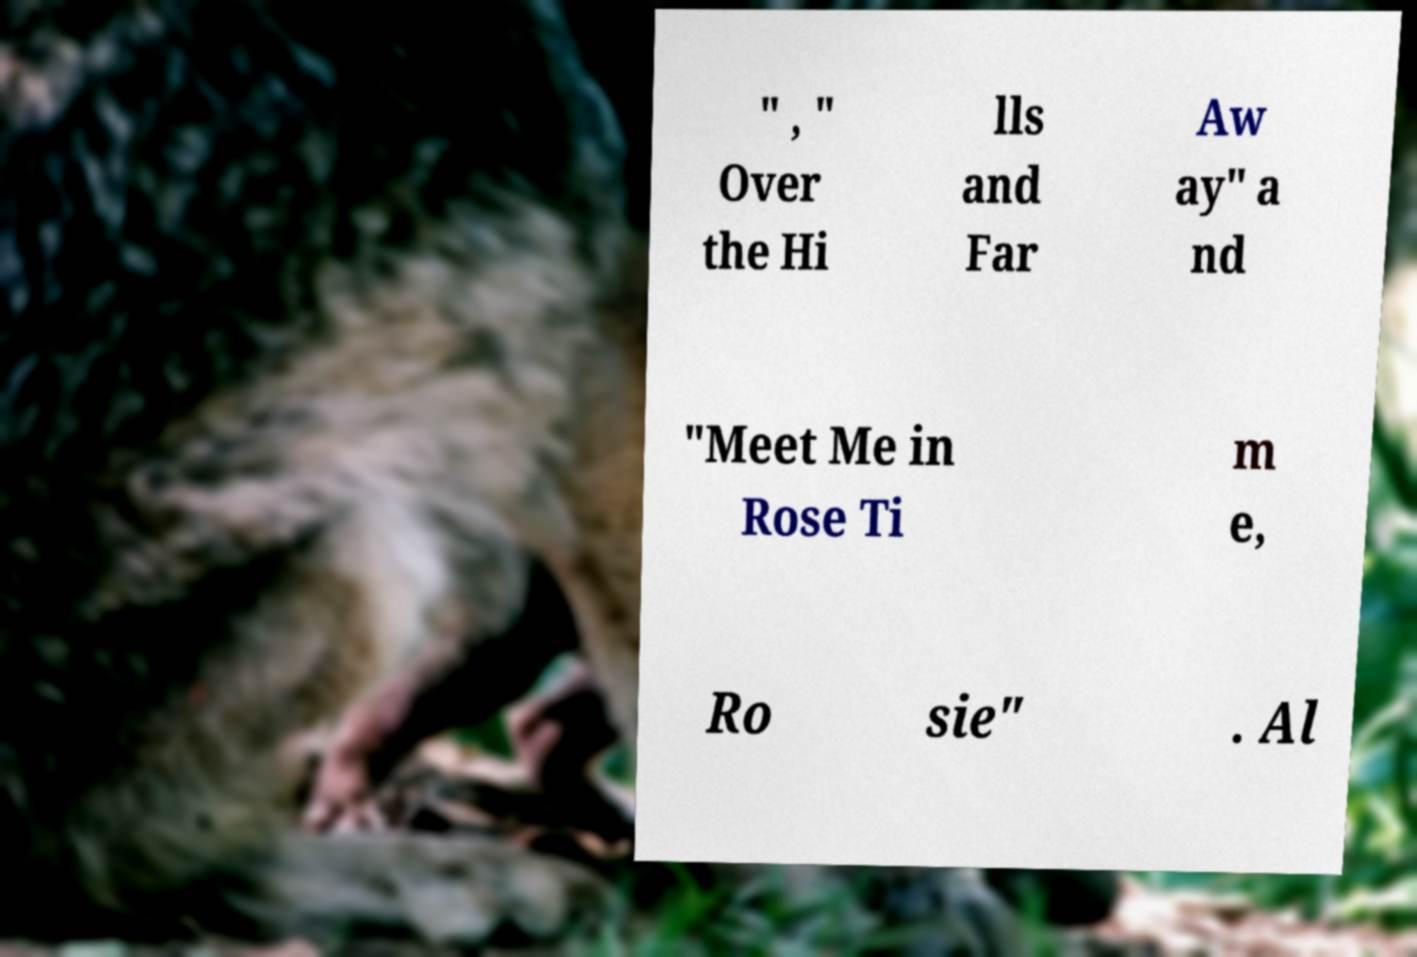Could you assist in decoding the text presented in this image and type it out clearly? " , " Over the Hi lls and Far Aw ay" a nd "Meet Me in Rose Ti m e, Ro sie" . Al 